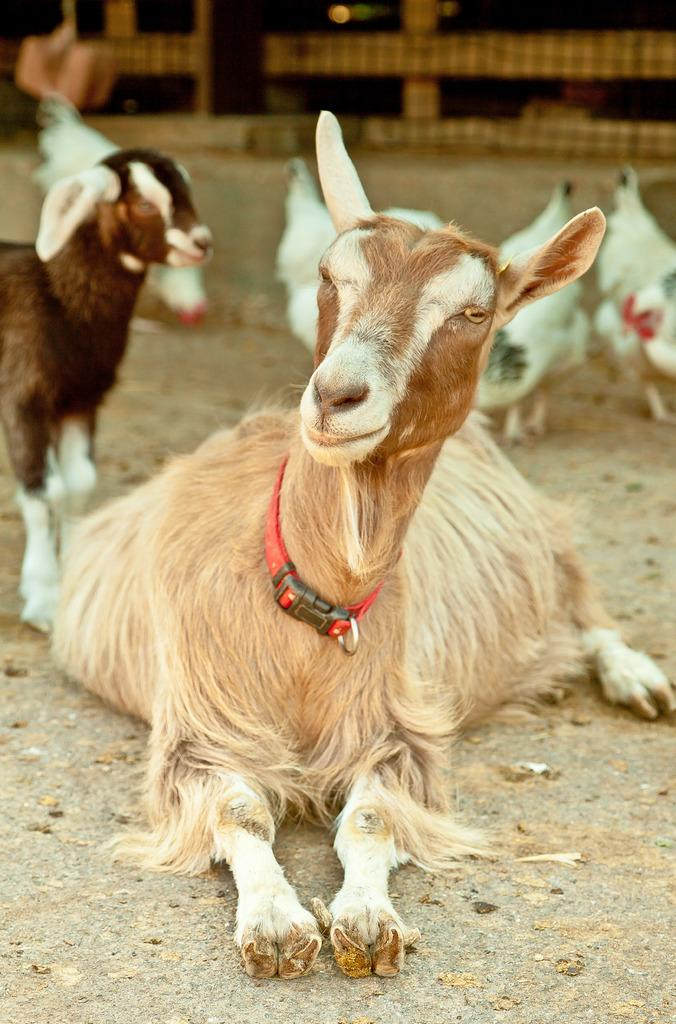What type of animals can be seen in the image? There are goats and hens in the image. Can you describe the setting where the animals are located? The provided facts do not give information about the setting, so it cannot be described. What type of drum can be seen in the image? There is no drum present in the image; it features goats and hens. What type of match can be seen in the image? There is no match present in the image. 